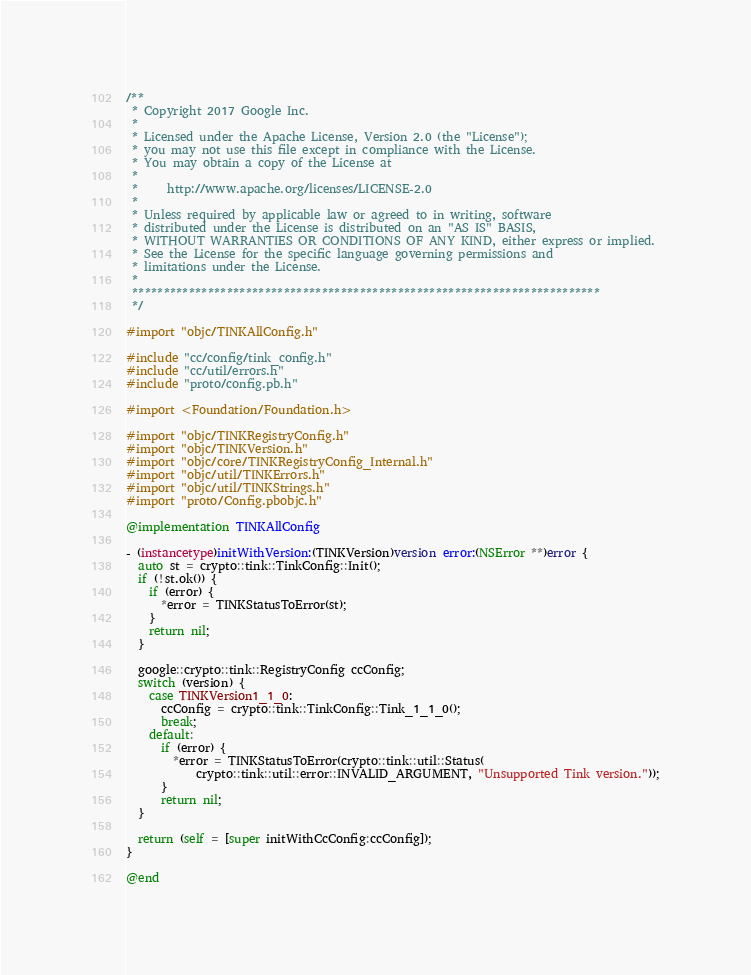Convert code to text. <code><loc_0><loc_0><loc_500><loc_500><_ObjectiveC_>/**
 * Copyright 2017 Google Inc.
 *
 * Licensed under the Apache License, Version 2.0 (the "License");
 * you may not use this file except in compliance with the License.
 * You may obtain a copy of the License at
 *
 *     http://www.apache.org/licenses/LICENSE-2.0
 *
 * Unless required by applicable law or agreed to in writing, software
 * distributed under the License is distributed on an "AS IS" BASIS,
 * WITHOUT WARRANTIES OR CONDITIONS OF ANY KIND, either express or implied.
 * See the License for the specific language governing permissions and
 * limitations under the License.
 *
 **************************************************************************
 */

#import "objc/TINKAllConfig.h"

#include "cc/config/tink_config.h"
#include "cc/util/errors.h"
#include "proto/config.pb.h"

#import <Foundation/Foundation.h>

#import "objc/TINKRegistryConfig.h"
#import "objc/TINKVersion.h"
#import "objc/core/TINKRegistryConfig_Internal.h"
#import "objc/util/TINKErrors.h"
#import "objc/util/TINKStrings.h"
#import "proto/Config.pbobjc.h"

@implementation TINKAllConfig

- (instancetype)initWithVersion:(TINKVersion)version error:(NSError **)error {
  auto st = crypto::tink::TinkConfig::Init();
  if (!st.ok()) {
    if (error) {
      *error = TINKStatusToError(st);
    }
    return nil;
  }

  google::crypto::tink::RegistryConfig ccConfig;
  switch (version) {
    case TINKVersion1_1_0:
      ccConfig = crypto::tink::TinkConfig::Tink_1_1_0();
      break;
    default:
      if (error) {
        *error = TINKStatusToError(crypto::tink::util::Status(
            crypto::tink::util::error::INVALID_ARGUMENT, "Unsupported Tink version."));
      }
      return nil;
  }

  return (self = [super initWithCcConfig:ccConfig]);
}

@end
</code> 